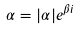Convert formula to latex. <formula><loc_0><loc_0><loc_500><loc_500>\alpha = | \alpha | e ^ { \beta i }</formula> 